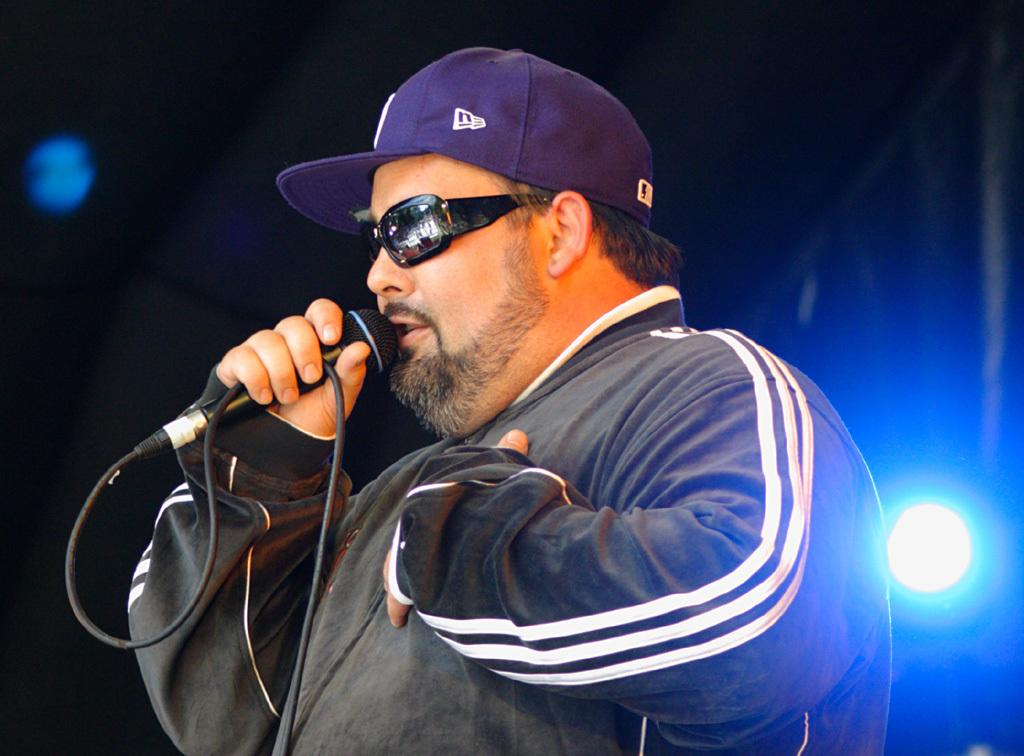Who is the main subject in the image? There is a man in the image. What is the man holding in the image? The man is holding a microphone. What might the man be doing with the microphone? The man may be singing. What type of protective eyewear is the man wearing? The man is wearing goggles. What type of headwear is the man wearing? The man is wearing a cap. What can be seen in the background of the image? There are fancy lights visible in the background. What type of oil can be seen dripping from the man's hand in the image? There is no oil visible on the man's hand in the image. How many kittens are sitting on the man's shoulder in the image? There are no kittens present in the image. 